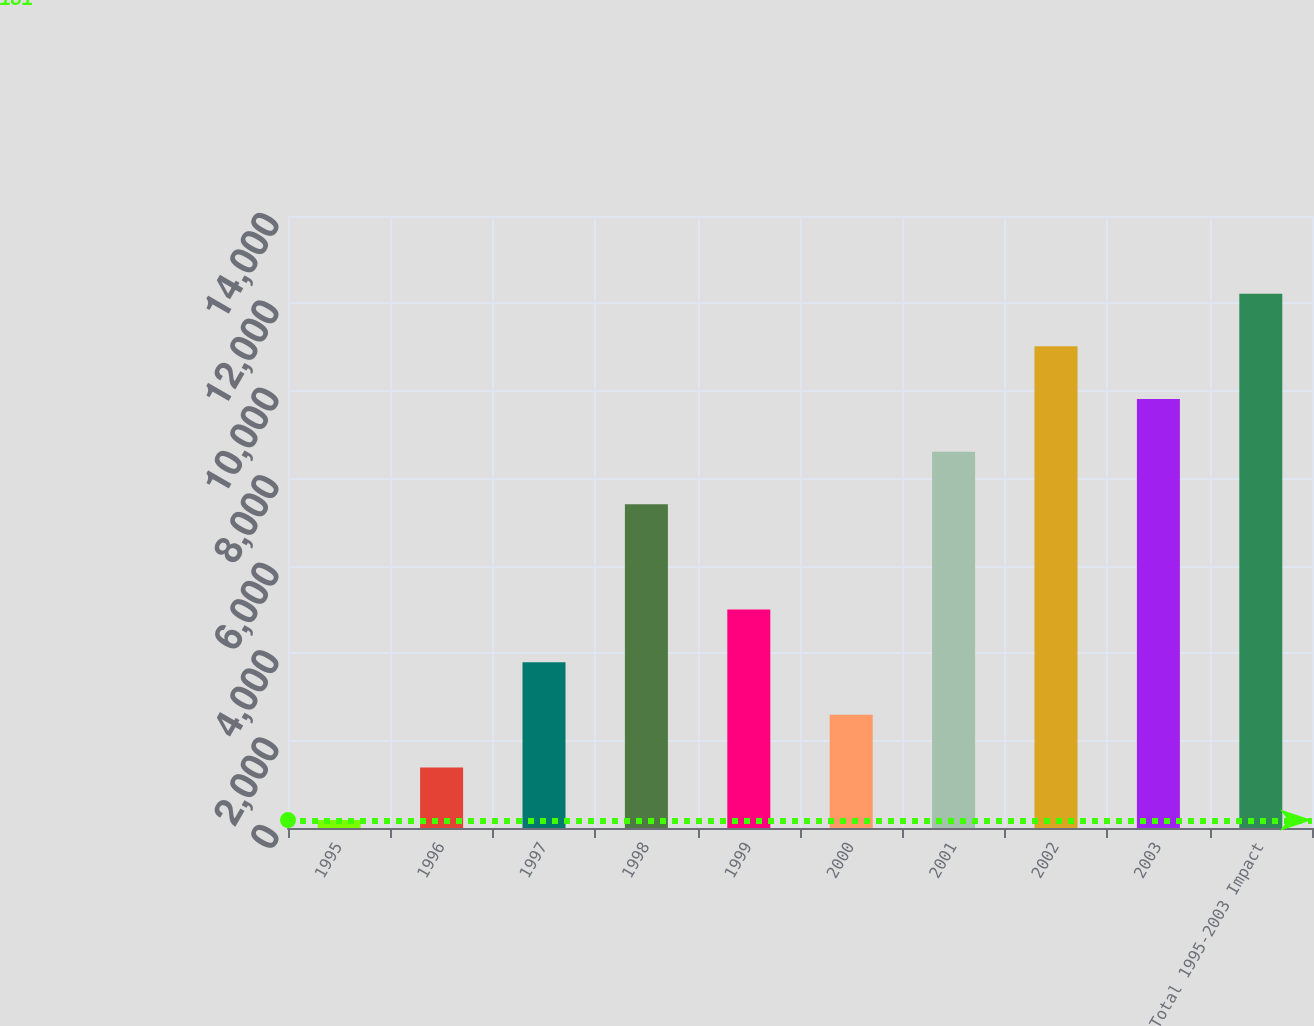Convert chart to OTSL. <chart><loc_0><loc_0><loc_500><loc_500><bar_chart><fcel>1995<fcel>1996<fcel>1997<fcel>1998<fcel>1999<fcel>2000<fcel>2001<fcel>2002<fcel>2003<fcel>Total 1995-2003 Impact<nl><fcel>181<fcel>1385.1<fcel>3793.3<fcel>7405.6<fcel>4997.4<fcel>2589.2<fcel>8609.7<fcel>11017.9<fcel>9813.8<fcel>12222<nl></chart> 